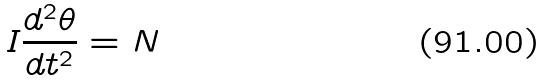<formula> <loc_0><loc_0><loc_500><loc_500>I \frac { d ^ { 2 } \theta } { d t ^ { 2 } } = N</formula> 